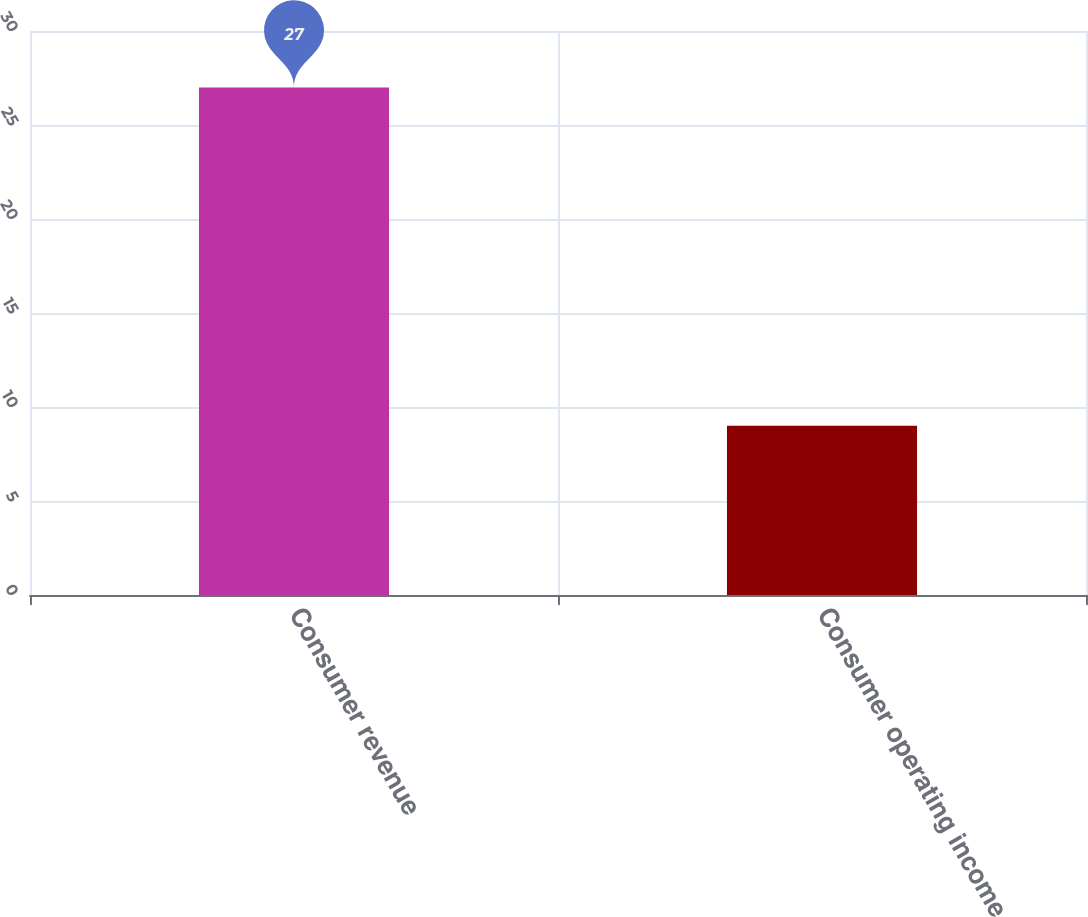Convert chart. <chart><loc_0><loc_0><loc_500><loc_500><bar_chart><fcel>Consumer revenue<fcel>Consumer operating income<nl><fcel>27<fcel>9<nl></chart> 